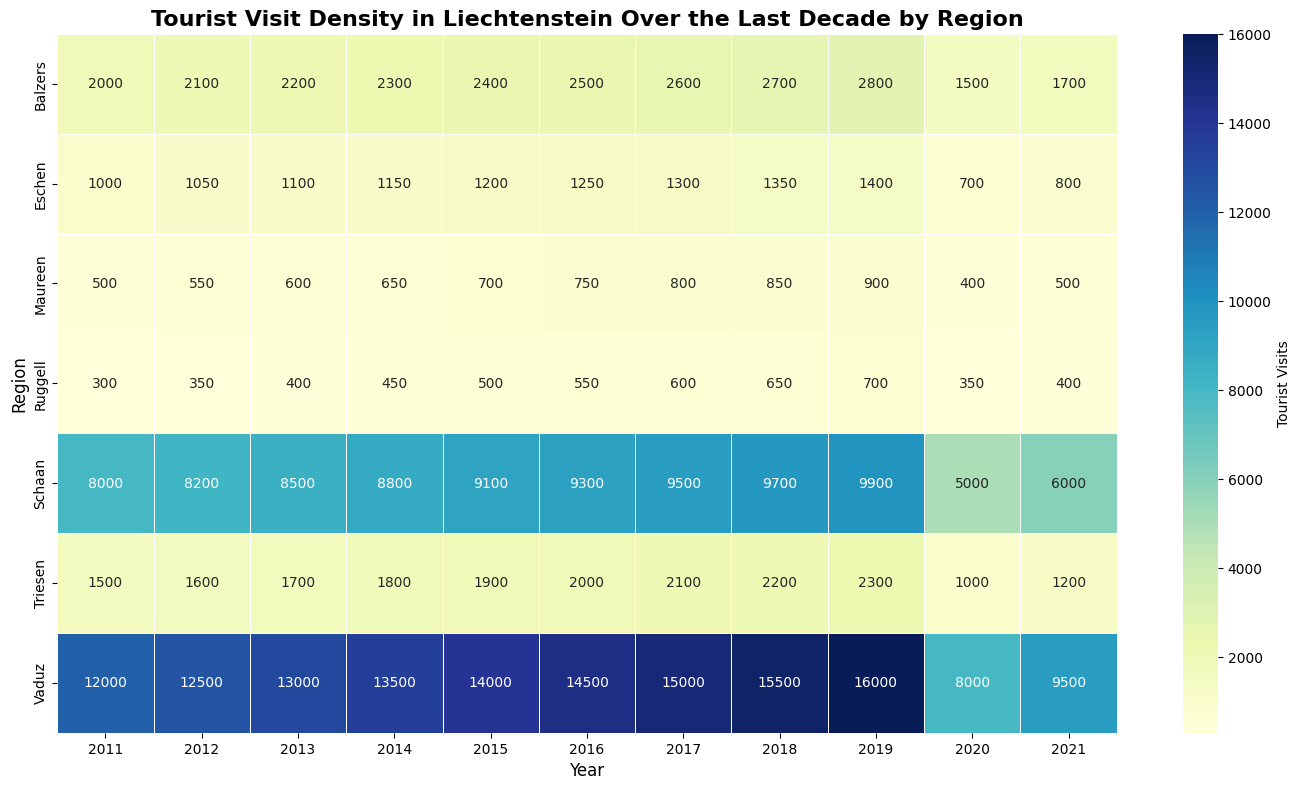Which region had the highest number of tourist visits in 2019? Look at the column for 2019. Identify the cell with the highest value.
Answer: Vaduz Which region had the fewest tourist visits in 2020? Look at the column for 2020. Identify the cell with the lowest value.
Answer: Ruggell How did the tourist visits in Schaan compare between 2019 and 2020? Find the values for Schaan in 2019 and 2020, then subtract the 2020 value from the 2019 value. Schaan (2019) - Schaan (2020) = 9900 - 5000.
Answer: Decreased by 4900 Which year had the highest number of tourist visits in Vaduz? Look at the row for Vaduz and find the year with the highest value.
Answer: 2019 What was the total number of tourist visits in Triesen from 2011 to 2021? Sum the values in the row for Triesen from 2011 to 2021. 1500 + 1600 + 1700 + 1800 + 1900 + 2000 + 2100 + 2200 + 2300 + 1000 + 1200.
Answer: 20100 Which region showed the most drastic drop in tourist visits in 2020 compared to 2019? Calculate the difference in visits between 2019 and 2020 for each region, and identify the region with the highest drop. For example, Schaan: 9900-5000 = 4900, Vaduz: 16000-8000 = 8000. Find the maximum drop.
Answer: Vaduz In which year did Maureen see the highest tourist visits? Look at the row for Maureen and find the year with the highest value.
Answer: 2019 What is the average number of tourist visits in Eschen over the decade? Sum the values in the row for Eschen and divide by the number of years (11). 1000 + 1050 + 1100 + 1150 + 1200 + 1250 + 1300 + 1350 + 1400 + 700 + 800 = 12200, 12200/11.
Answer: 1109 (rounded to nearest whole) Which region had the highest consistent increase in tourist visits year over year before 2020? Compare year over year visits for each region from 2011 to 2019. The region with a consistent increase each year is identified.
Answer: Vaduz What is the percentage decrease in tourist visits in Balzers from 2019 to 2020? Find the values for Balzers in 2019 and 2020. Calculate the decrease: 2800 - 1500 = 1300. Then divide by the 2019 value and multiply by 100. 1300/2800 * 100 = 46.4%.
Answer: 46.4% 